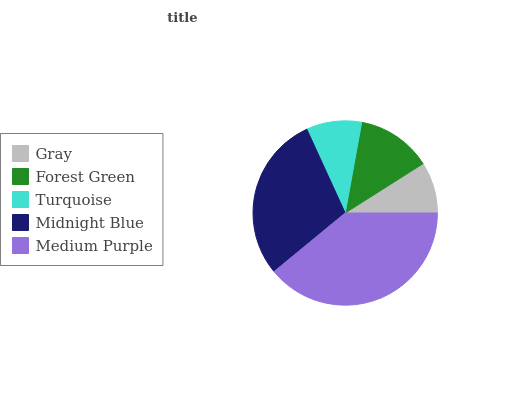Is Gray the minimum?
Answer yes or no. Yes. Is Medium Purple the maximum?
Answer yes or no. Yes. Is Forest Green the minimum?
Answer yes or no. No. Is Forest Green the maximum?
Answer yes or no. No. Is Forest Green greater than Gray?
Answer yes or no. Yes. Is Gray less than Forest Green?
Answer yes or no. Yes. Is Gray greater than Forest Green?
Answer yes or no. No. Is Forest Green less than Gray?
Answer yes or no. No. Is Forest Green the high median?
Answer yes or no. Yes. Is Forest Green the low median?
Answer yes or no. Yes. Is Midnight Blue the high median?
Answer yes or no. No. Is Medium Purple the low median?
Answer yes or no. No. 